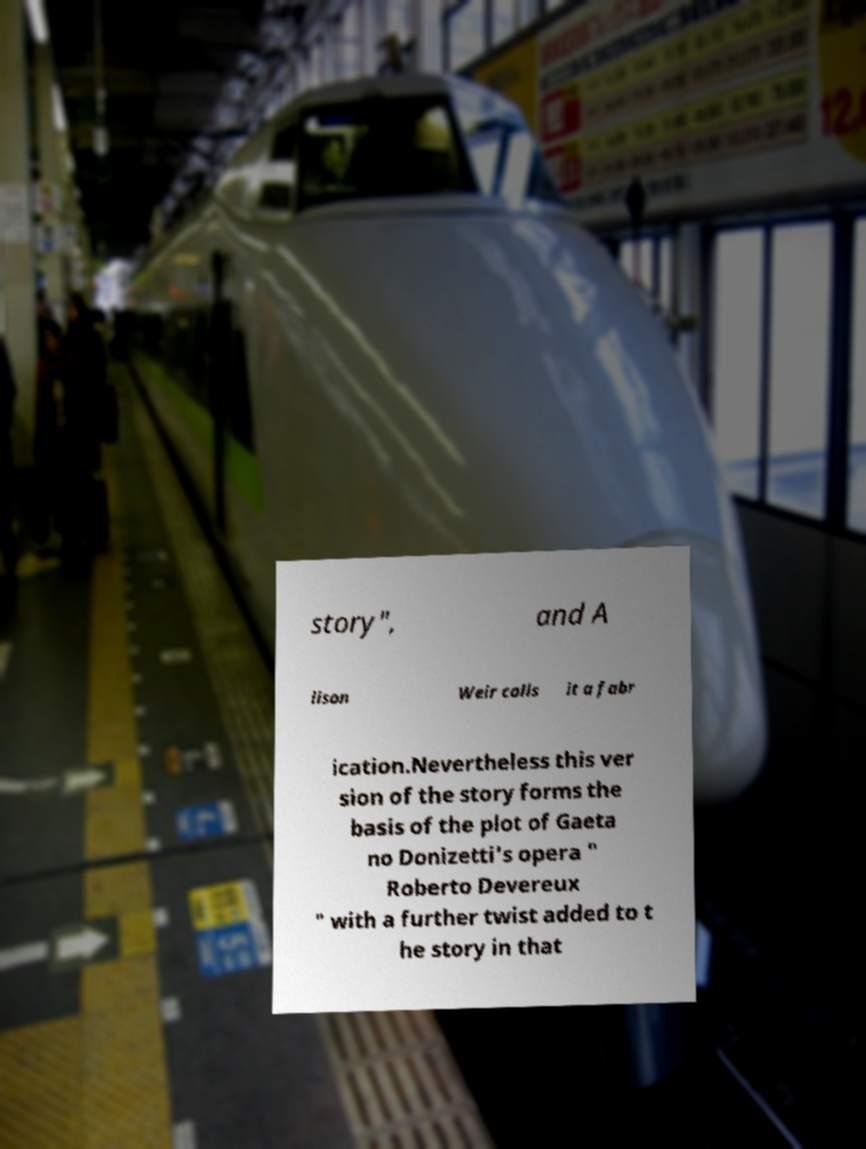Could you extract and type out the text from this image? story", and A lison Weir calls it a fabr ication.Nevertheless this ver sion of the story forms the basis of the plot of Gaeta no Donizetti's opera " Roberto Devereux " with a further twist added to t he story in that 